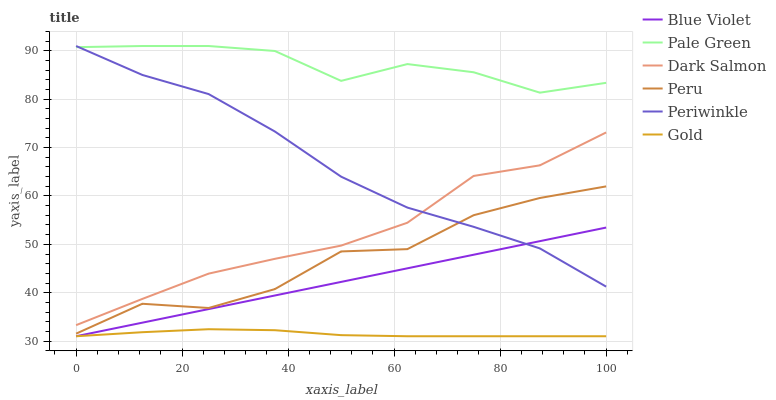Does Gold have the minimum area under the curve?
Answer yes or no. Yes. Does Pale Green have the maximum area under the curve?
Answer yes or no. Yes. Does Dark Salmon have the minimum area under the curve?
Answer yes or no. No. Does Dark Salmon have the maximum area under the curve?
Answer yes or no. No. Is Blue Violet the smoothest?
Answer yes or no. Yes. Is Peru the roughest?
Answer yes or no. Yes. Is Dark Salmon the smoothest?
Answer yes or no. No. Is Dark Salmon the roughest?
Answer yes or no. No. Does Dark Salmon have the lowest value?
Answer yes or no. No. Does Periwinkle have the highest value?
Answer yes or no. Yes. Does Dark Salmon have the highest value?
Answer yes or no. No. Is Peru less than Dark Salmon?
Answer yes or no. Yes. Is Periwinkle greater than Gold?
Answer yes or no. Yes. Does Periwinkle intersect Pale Green?
Answer yes or no. Yes. Is Periwinkle less than Pale Green?
Answer yes or no. No. Is Periwinkle greater than Pale Green?
Answer yes or no. No. Does Peru intersect Dark Salmon?
Answer yes or no. No. 